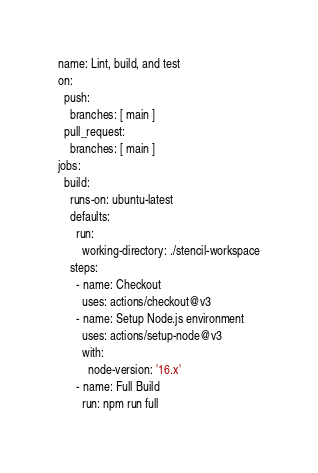Convert code to text. <code><loc_0><loc_0><loc_500><loc_500><_YAML_>name: Lint, build, and test
on:
  push:
    branches: [ main ]
  pull_request:
    branches: [ main ]
jobs:
  build:
    runs-on: ubuntu-latest
    defaults:
      run:
        working-directory: ./stencil-workspace
    steps:
      - name: Checkout
        uses: actions/checkout@v3
      - name: Setup Node.js environment
        uses: actions/setup-node@v3
        with:
          node-version: '16.x'
      - name: Full Build
        run: npm run full
</code> 